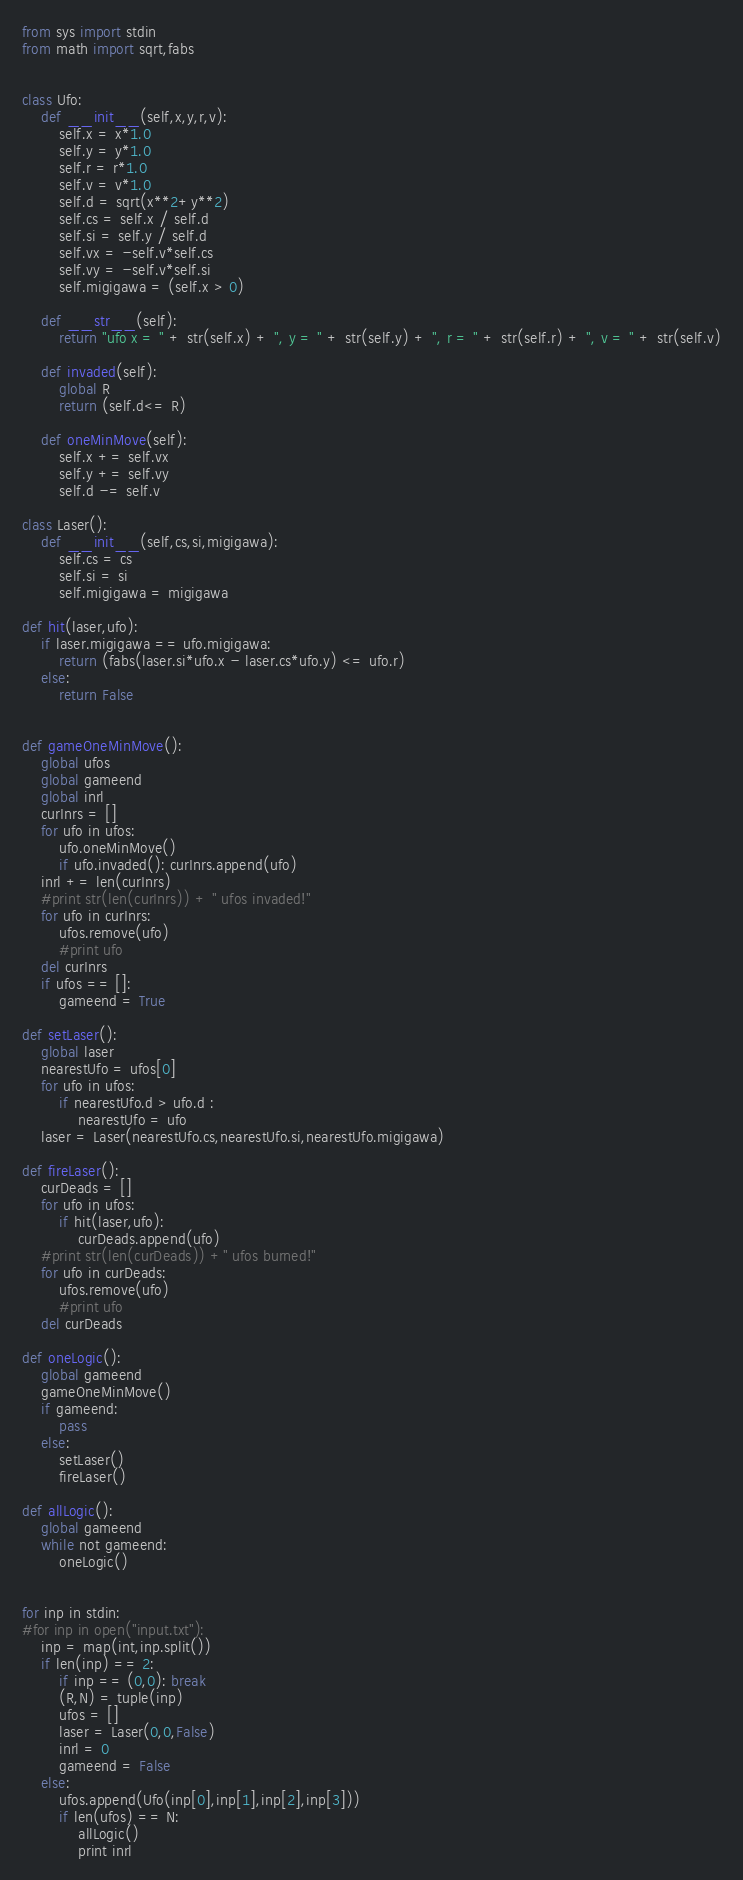Convert code to text. <code><loc_0><loc_0><loc_500><loc_500><_Python_>from sys import stdin
from math import sqrt,fabs


class Ufo:
	def __init__(self,x,y,r,v):
		self.x = x*1.0
		self.y = y*1.0
		self.r = r*1.0
		self.v = v*1.0
		self.d = sqrt(x**2+y**2)
		self.cs = self.x / self.d
		self.si = self.y / self.d
		self.vx = -self.v*self.cs
		self.vy = -self.v*self.si
		self.migigawa = (self.x > 0)

	def __str__(self):
		return "ufo x = " + str(self.x) + ", y = " + str(self.y) + ", r = " + str(self.r) + ", v = " + str(self.v)

	def invaded(self):
		global R
		return (self.d<= R)

	def oneMinMove(self):
		self.x += self.vx
		self.y += self.vy
		self.d -= self.v

class Laser():
	def __init__(self,cs,si,migigawa):
		self.cs = cs
		self.si = si
		self.migigawa = migigawa

def hit(laser,ufo):
	if laser.migigawa == ufo.migigawa: 
		return (fabs(laser.si*ufo.x - laser.cs*ufo.y) <= ufo.r)
	else:
		return False


def gameOneMinMove():
	global ufos
	global gameend
	global inrl
	curInrs = []
	for ufo in ufos:
		ufo.oneMinMove()
		if ufo.invaded(): curInrs.append(ufo)
	inrl += len(curInrs)
	#print str(len(curInrs)) + " ufos invaded!"
	for ufo in curInrs:
		ufos.remove(ufo)
		#print ufo
	del curInrs
	if ufos == []:
		gameend = True

def setLaser():
	global laser
	nearestUfo = ufos[0]
	for ufo in ufos:
		if nearestUfo.d > ufo.d :
			nearestUfo = ufo
	laser = Laser(nearestUfo.cs,nearestUfo.si,nearestUfo.migigawa)

def fireLaser():
	curDeads = []
	for ufo in ufos:
		if hit(laser,ufo):
			curDeads.append(ufo)
	#print str(len(curDeads)) +" ufos burned!"
	for ufo in curDeads:
		ufos.remove(ufo)
		#print ufo
	del curDeads

def oneLogic():
	global gameend
	gameOneMinMove()
	if gameend:
		pass
	else:
		setLaser()
		fireLaser()

def allLogic():
	global gameend
	while not gameend:
		oneLogic()


for inp in stdin:
#for inp in open("input.txt"):
	inp = map(int,inp.split())
	if len(inp) == 2:
		if inp == (0,0): break
		(R,N) = tuple(inp)
		ufos = []
		laser = Laser(0,0,False)
		inrl = 0
		gameend = False
	else:
		ufos.append(Ufo(inp[0],inp[1],inp[2],inp[3]))
		if len(ufos) == N:
			allLogic()
			print inrl</code> 